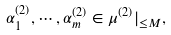<formula> <loc_0><loc_0><loc_500><loc_500>\alpha ^ { ( 2 ) } _ { 1 } , \cdots , \alpha ^ { ( 2 ) } _ { m } \in \mu ^ { ( 2 ) } | _ { \leq M } ,</formula> 